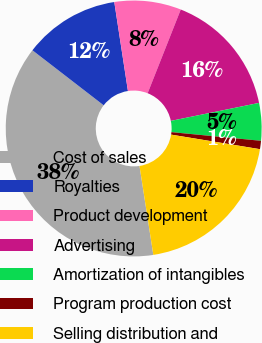Convert chart. <chart><loc_0><loc_0><loc_500><loc_500><pie_chart><fcel>Cost of sales<fcel>Royalties<fcel>Product development<fcel>Advertising<fcel>Amortization of intangibles<fcel>Program production cost<fcel>Selling distribution and<nl><fcel>37.92%<fcel>12.11%<fcel>8.42%<fcel>15.8%<fcel>4.74%<fcel>1.05%<fcel>19.96%<nl></chart> 